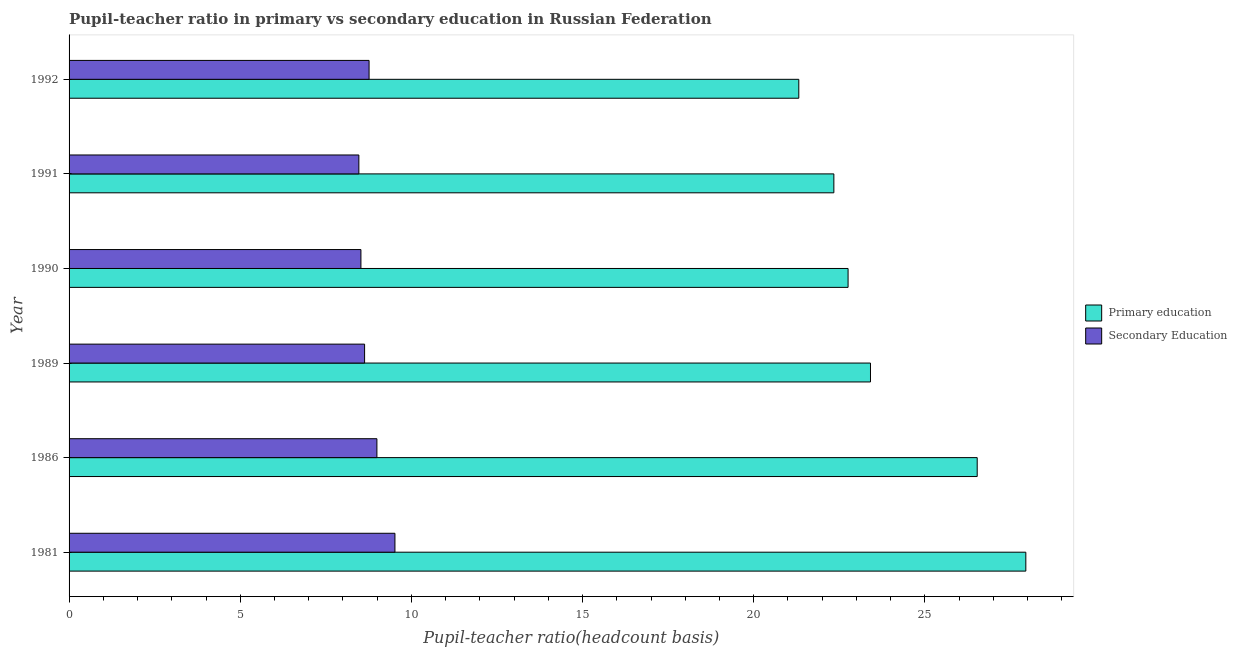Are the number of bars per tick equal to the number of legend labels?
Offer a terse response. Yes. Are the number of bars on each tick of the Y-axis equal?
Your response must be concise. Yes. What is the pupil teacher ratio on secondary education in 1989?
Provide a succinct answer. 8.63. Across all years, what is the maximum pupil-teacher ratio in primary education?
Make the answer very short. 27.95. Across all years, what is the minimum pupil-teacher ratio in primary education?
Ensure brevity in your answer.  21.32. What is the total pupil-teacher ratio in primary education in the graph?
Ensure brevity in your answer.  144.3. What is the difference between the pupil-teacher ratio in primary education in 1981 and that in 1991?
Your answer should be very brief. 5.61. What is the difference between the pupil teacher ratio on secondary education in 1981 and the pupil-teacher ratio in primary education in 1991?
Provide a short and direct response. -12.82. What is the average pupil teacher ratio on secondary education per year?
Ensure brevity in your answer.  8.82. In the year 1989, what is the difference between the pupil-teacher ratio in primary education and pupil teacher ratio on secondary education?
Your answer should be compact. 14.78. What is the ratio of the pupil-teacher ratio in primary education in 1989 to that in 1991?
Provide a succinct answer. 1.05. Is the pupil teacher ratio on secondary education in 1989 less than that in 1990?
Provide a short and direct response. No. Is the difference between the pupil teacher ratio on secondary education in 1981 and 1992 greater than the difference between the pupil-teacher ratio in primary education in 1981 and 1992?
Keep it short and to the point. No. What is the difference between the highest and the second highest pupil teacher ratio on secondary education?
Offer a terse response. 0.53. What is the difference between the highest and the lowest pupil teacher ratio on secondary education?
Offer a terse response. 1.05. In how many years, is the pupil teacher ratio on secondary education greater than the average pupil teacher ratio on secondary education taken over all years?
Keep it short and to the point. 2. Is the sum of the pupil-teacher ratio in primary education in 1986 and 1992 greater than the maximum pupil teacher ratio on secondary education across all years?
Keep it short and to the point. Yes. What does the 2nd bar from the top in 1981 represents?
Your response must be concise. Primary education. What does the 2nd bar from the bottom in 1981 represents?
Offer a very short reply. Secondary Education. How many years are there in the graph?
Your response must be concise. 6. What is the difference between two consecutive major ticks on the X-axis?
Your answer should be very brief. 5. Are the values on the major ticks of X-axis written in scientific E-notation?
Your answer should be compact. No. Does the graph contain any zero values?
Provide a short and direct response. No. Where does the legend appear in the graph?
Give a very brief answer. Center right. What is the title of the graph?
Provide a short and direct response. Pupil-teacher ratio in primary vs secondary education in Russian Federation. Does "Start a business" appear as one of the legend labels in the graph?
Give a very brief answer. No. What is the label or title of the X-axis?
Your answer should be compact. Pupil-teacher ratio(headcount basis). What is the label or title of the Y-axis?
Your answer should be very brief. Year. What is the Pupil-teacher ratio(headcount basis) of Primary education in 1981?
Make the answer very short. 27.95. What is the Pupil-teacher ratio(headcount basis) of Secondary Education in 1981?
Offer a terse response. 9.52. What is the Pupil-teacher ratio(headcount basis) in Primary education in 1986?
Keep it short and to the point. 26.53. What is the Pupil-teacher ratio(headcount basis) in Secondary Education in 1986?
Your answer should be compact. 8.99. What is the Pupil-teacher ratio(headcount basis) in Primary education in 1989?
Ensure brevity in your answer.  23.41. What is the Pupil-teacher ratio(headcount basis) of Secondary Education in 1989?
Your response must be concise. 8.63. What is the Pupil-teacher ratio(headcount basis) in Primary education in 1990?
Your answer should be compact. 22.76. What is the Pupil-teacher ratio(headcount basis) in Secondary Education in 1990?
Keep it short and to the point. 8.53. What is the Pupil-teacher ratio(headcount basis) of Primary education in 1991?
Give a very brief answer. 22.34. What is the Pupil-teacher ratio(headcount basis) of Secondary Education in 1991?
Provide a succinct answer. 8.47. What is the Pupil-teacher ratio(headcount basis) in Primary education in 1992?
Your answer should be very brief. 21.32. What is the Pupil-teacher ratio(headcount basis) in Secondary Education in 1992?
Make the answer very short. 8.76. Across all years, what is the maximum Pupil-teacher ratio(headcount basis) of Primary education?
Offer a very short reply. 27.95. Across all years, what is the maximum Pupil-teacher ratio(headcount basis) of Secondary Education?
Keep it short and to the point. 9.52. Across all years, what is the minimum Pupil-teacher ratio(headcount basis) in Primary education?
Keep it short and to the point. 21.32. Across all years, what is the minimum Pupil-teacher ratio(headcount basis) of Secondary Education?
Offer a very short reply. 8.47. What is the total Pupil-teacher ratio(headcount basis) of Primary education in the graph?
Offer a terse response. 144.3. What is the total Pupil-teacher ratio(headcount basis) of Secondary Education in the graph?
Your answer should be compact. 52.9. What is the difference between the Pupil-teacher ratio(headcount basis) in Primary education in 1981 and that in 1986?
Provide a succinct answer. 1.42. What is the difference between the Pupil-teacher ratio(headcount basis) in Secondary Education in 1981 and that in 1986?
Your answer should be compact. 0.53. What is the difference between the Pupil-teacher ratio(headcount basis) of Primary education in 1981 and that in 1989?
Provide a succinct answer. 4.54. What is the difference between the Pupil-teacher ratio(headcount basis) in Secondary Education in 1981 and that in 1989?
Make the answer very short. 0.89. What is the difference between the Pupil-teacher ratio(headcount basis) of Primary education in 1981 and that in 1990?
Provide a short and direct response. 5.19. What is the difference between the Pupil-teacher ratio(headcount basis) in Primary education in 1981 and that in 1991?
Keep it short and to the point. 5.61. What is the difference between the Pupil-teacher ratio(headcount basis) in Secondary Education in 1981 and that in 1991?
Keep it short and to the point. 1.05. What is the difference between the Pupil-teacher ratio(headcount basis) in Primary education in 1981 and that in 1992?
Your answer should be compact. 6.63. What is the difference between the Pupil-teacher ratio(headcount basis) of Secondary Education in 1981 and that in 1992?
Your answer should be compact. 0.76. What is the difference between the Pupil-teacher ratio(headcount basis) in Primary education in 1986 and that in 1989?
Ensure brevity in your answer.  3.12. What is the difference between the Pupil-teacher ratio(headcount basis) in Secondary Education in 1986 and that in 1989?
Ensure brevity in your answer.  0.36. What is the difference between the Pupil-teacher ratio(headcount basis) in Primary education in 1986 and that in 1990?
Offer a terse response. 3.77. What is the difference between the Pupil-teacher ratio(headcount basis) of Secondary Education in 1986 and that in 1990?
Provide a short and direct response. 0.47. What is the difference between the Pupil-teacher ratio(headcount basis) in Primary education in 1986 and that in 1991?
Keep it short and to the point. 4.19. What is the difference between the Pupil-teacher ratio(headcount basis) of Secondary Education in 1986 and that in 1991?
Provide a succinct answer. 0.53. What is the difference between the Pupil-teacher ratio(headcount basis) of Primary education in 1986 and that in 1992?
Ensure brevity in your answer.  5.21. What is the difference between the Pupil-teacher ratio(headcount basis) in Secondary Education in 1986 and that in 1992?
Your response must be concise. 0.23. What is the difference between the Pupil-teacher ratio(headcount basis) of Primary education in 1989 and that in 1990?
Keep it short and to the point. 0.65. What is the difference between the Pupil-teacher ratio(headcount basis) of Secondary Education in 1989 and that in 1990?
Provide a succinct answer. 0.11. What is the difference between the Pupil-teacher ratio(headcount basis) in Primary education in 1989 and that in 1991?
Offer a terse response. 1.07. What is the difference between the Pupil-teacher ratio(headcount basis) in Secondary Education in 1989 and that in 1991?
Provide a short and direct response. 0.17. What is the difference between the Pupil-teacher ratio(headcount basis) of Primary education in 1989 and that in 1992?
Give a very brief answer. 2.09. What is the difference between the Pupil-teacher ratio(headcount basis) in Secondary Education in 1989 and that in 1992?
Provide a succinct answer. -0.13. What is the difference between the Pupil-teacher ratio(headcount basis) of Primary education in 1990 and that in 1991?
Offer a terse response. 0.42. What is the difference between the Pupil-teacher ratio(headcount basis) of Secondary Education in 1990 and that in 1991?
Your answer should be very brief. 0.06. What is the difference between the Pupil-teacher ratio(headcount basis) of Primary education in 1990 and that in 1992?
Make the answer very short. 1.44. What is the difference between the Pupil-teacher ratio(headcount basis) of Secondary Education in 1990 and that in 1992?
Your answer should be very brief. -0.24. What is the difference between the Pupil-teacher ratio(headcount basis) of Primary education in 1991 and that in 1992?
Ensure brevity in your answer.  1.02. What is the difference between the Pupil-teacher ratio(headcount basis) in Secondary Education in 1991 and that in 1992?
Offer a terse response. -0.3. What is the difference between the Pupil-teacher ratio(headcount basis) in Primary education in 1981 and the Pupil-teacher ratio(headcount basis) in Secondary Education in 1986?
Your answer should be very brief. 18.96. What is the difference between the Pupil-teacher ratio(headcount basis) in Primary education in 1981 and the Pupil-teacher ratio(headcount basis) in Secondary Education in 1989?
Your response must be concise. 19.32. What is the difference between the Pupil-teacher ratio(headcount basis) of Primary education in 1981 and the Pupil-teacher ratio(headcount basis) of Secondary Education in 1990?
Ensure brevity in your answer.  19.42. What is the difference between the Pupil-teacher ratio(headcount basis) of Primary education in 1981 and the Pupil-teacher ratio(headcount basis) of Secondary Education in 1991?
Give a very brief answer. 19.48. What is the difference between the Pupil-teacher ratio(headcount basis) of Primary education in 1981 and the Pupil-teacher ratio(headcount basis) of Secondary Education in 1992?
Ensure brevity in your answer.  19.19. What is the difference between the Pupil-teacher ratio(headcount basis) of Primary education in 1986 and the Pupil-teacher ratio(headcount basis) of Secondary Education in 1989?
Offer a very short reply. 17.9. What is the difference between the Pupil-teacher ratio(headcount basis) of Primary education in 1986 and the Pupil-teacher ratio(headcount basis) of Secondary Education in 1990?
Provide a short and direct response. 18. What is the difference between the Pupil-teacher ratio(headcount basis) in Primary education in 1986 and the Pupil-teacher ratio(headcount basis) in Secondary Education in 1991?
Keep it short and to the point. 18.06. What is the difference between the Pupil-teacher ratio(headcount basis) in Primary education in 1986 and the Pupil-teacher ratio(headcount basis) in Secondary Education in 1992?
Your answer should be compact. 17.76. What is the difference between the Pupil-teacher ratio(headcount basis) of Primary education in 1989 and the Pupil-teacher ratio(headcount basis) of Secondary Education in 1990?
Ensure brevity in your answer.  14.89. What is the difference between the Pupil-teacher ratio(headcount basis) of Primary education in 1989 and the Pupil-teacher ratio(headcount basis) of Secondary Education in 1991?
Offer a very short reply. 14.95. What is the difference between the Pupil-teacher ratio(headcount basis) in Primary education in 1989 and the Pupil-teacher ratio(headcount basis) in Secondary Education in 1992?
Your answer should be compact. 14.65. What is the difference between the Pupil-teacher ratio(headcount basis) of Primary education in 1990 and the Pupil-teacher ratio(headcount basis) of Secondary Education in 1991?
Your answer should be very brief. 14.29. What is the difference between the Pupil-teacher ratio(headcount basis) in Primary education in 1990 and the Pupil-teacher ratio(headcount basis) in Secondary Education in 1992?
Offer a very short reply. 13.99. What is the difference between the Pupil-teacher ratio(headcount basis) in Primary education in 1991 and the Pupil-teacher ratio(headcount basis) in Secondary Education in 1992?
Give a very brief answer. 13.58. What is the average Pupil-teacher ratio(headcount basis) in Primary education per year?
Offer a very short reply. 24.05. What is the average Pupil-teacher ratio(headcount basis) in Secondary Education per year?
Keep it short and to the point. 8.82. In the year 1981, what is the difference between the Pupil-teacher ratio(headcount basis) of Primary education and Pupil-teacher ratio(headcount basis) of Secondary Education?
Provide a short and direct response. 18.43. In the year 1986, what is the difference between the Pupil-teacher ratio(headcount basis) of Primary education and Pupil-teacher ratio(headcount basis) of Secondary Education?
Offer a very short reply. 17.54. In the year 1989, what is the difference between the Pupil-teacher ratio(headcount basis) of Primary education and Pupil-teacher ratio(headcount basis) of Secondary Education?
Your answer should be compact. 14.78. In the year 1990, what is the difference between the Pupil-teacher ratio(headcount basis) in Primary education and Pupil-teacher ratio(headcount basis) in Secondary Education?
Make the answer very short. 14.23. In the year 1991, what is the difference between the Pupil-teacher ratio(headcount basis) of Primary education and Pupil-teacher ratio(headcount basis) of Secondary Education?
Offer a terse response. 13.88. In the year 1992, what is the difference between the Pupil-teacher ratio(headcount basis) in Primary education and Pupil-teacher ratio(headcount basis) in Secondary Education?
Provide a short and direct response. 12.55. What is the ratio of the Pupil-teacher ratio(headcount basis) in Primary education in 1981 to that in 1986?
Provide a succinct answer. 1.05. What is the ratio of the Pupil-teacher ratio(headcount basis) of Secondary Education in 1981 to that in 1986?
Offer a terse response. 1.06. What is the ratio of the Pupil-teacher ratio(headcount basis) in Primary education in 1981 to that in 1989?
Your response must be concise. 1.19. What is the ratio of the Pupil-teacher ratio(headcount basis) in Secondary Education in 1981 to that in 1989?
Offer a very short reply. 1.1. What is the ratio of the Pupil-teacher ratio(headcount basis) in Primary education in 1981 to that in 1990?
Ensure brevity in your answer.  1.23. What is the ratio of the Pupil-teacher ratio(headcount basis) of Secondary Education in 1981 to that in 1990?
Your answer should be very brief. 1.12. What is the ratio of the Pupil-teacher ratio(headcount basis) of Primary education in 1981 to that in 1991?
Your answer should be compact. 1.25. What is the ratio of the Pupil-teacher ratio(headcount basis) of Secondary Education in 1981 to that in 1991?
Provide a succinct answer. 1.12. What is the ratio of the Pupil-teacher ratio(headcount basis) in Primary education in 1981 to that in 1992?
Give a very brief answer. 1.31. What is the ratio of the Pupil-teacher ratio(headcount basis) in Secondary Education in 1981 to that in 1992?
Offer a very short reply. 1.09. What is the ratio of the Pupil-teacher ratio(headcount basis) of Primary education in 1986 to that in 1989?
Your answer should be very brief. 1.13. What is the ratio of the Pupil-teacher ratio(headcount basis) in Secondary Education in 1986 to that in 1989?
Your answer should be very brief. 1.04. What is the ratio of the Pupil-teacher ratio(headcount basis) in Primary education in 1986 to that in 1990?
Give a very brief answer. 1.17. What is the ratio of the Pupil-teacher ratio(headcount basis) in Secondary Education in 1986 to that in 1990?
Ensure brevity in your answer.  1.05. What is the ratio of the Pupil-teacher ratio(headcount basis) of Primary education in 1986 to that in 1991?
Give a very brief answer. 1.19. What is the ratio of the Pupil-teacher ratio(headcount basis) in Secondary Education in 1986 to that in 1991?
Your answer should be compact. 1.06. What is the ratio of the Pupil-teacher ratio(headcount basis) in Primary education in 1986 to that in 1992?
Keep it short and to the point. 1.24. What is the ratio of the Pupil-teacher ratio(headcount basis) in Secondary Education in 1986 to that in 1992?
Offer a terse response. 1.03. What is the ratio of the Pupil-teacher ratio(headcount basis) in Primary education in 1989 to that in 1990?
Your answer should be compact. 1.03. What is the ratio of the Pupil-teacher ratio(headcount basis) in Secondary Education in 1989 to that in 1990?
Give a very brief answer. 1.01. What is the ratio of the Pupil-teacher ratio(headcount basis) of Primary education in 1989 to that in 1991?
Your answer should be very brief. 1.05. What is the ratio of the Pupil-teacher ratio(headcount basis) in Secondary Education in 1989 to that in 1991?
Give a very brief answer. 1.02. What is the ratio of the Pupil-teacher ratio(headcount basis) of Primary education in 1989 to that in 1992?
Ensure brevity in your answer.  1.1. What is the ratio of the Pupil-teacher ratio(headcount basis) of Secondary Education in 1989 to that in 1992?
Offer a terse response. 0.99. What is the ratio of the Pupil-teacher ratio(headcount basis) in Primary education in 1990 to that in 1991?
Your answer should be compact. 1.02. What is the ratio of the Pupil-teacher ratio(headcount basis) of Secondary Education in 1990 to that in 1991?
Keep it short and to the point. 1.01. What is the ratio of the Pupil-teacher ratio(headcount basis) in Primary education in 1990 to that in 1992?
Your response must be concise. 1.07. What is the ratio of the Pupil-teacher ratio(headcount basis) of Secondary Education in 1990 to that in 1992?
Give a very brief answer. 0.97. What is the ratio of the Pupil-teacher ratio(headcount basis) of Primary education in 1991 to that in 1992?
Your answer should be compact. 1.05. What is the ratio of the Pupil-teacher ratio(headcount basis) of Secondary Education in 1991 to that in 1992?
Ensure brevity in your answer.  0.97. What is the difference between the highest and the second highest Pupil-teacher ratio(headcount basis) in Primary education?
Ensure brevity in your answer.  1.42. What is the difference between the highest and the second highest Pupil-teacher ratio(headcount basis) of Secondary Education?
Ensure brevity in your answer.  0.53. What is the difference between the highest and the lowest Pupil-teacher ratio(headcount basis) of Primary education?
Provide a succinct answer. 6.63. What is the difference between the highest and the lowest Pupil-teacher ratio(headcount basis) of Secondary Education?
Offer a very short reply. 1.05. 